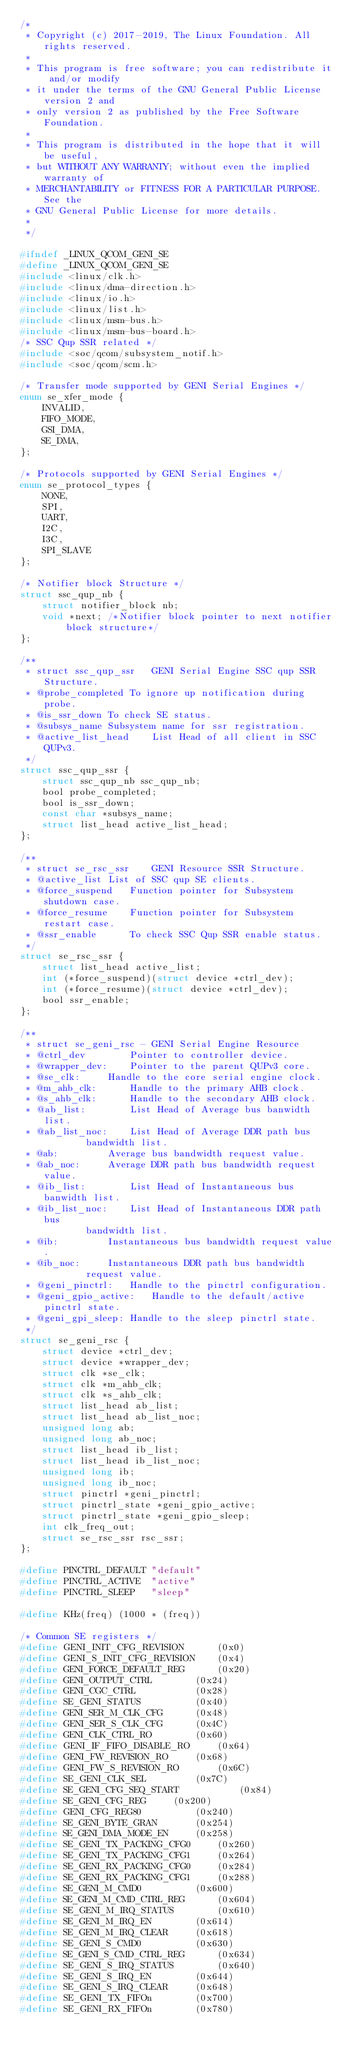Convert code to text. <code><loc_0><loc_0><loc_500><loc_500><_C_>/*
 * Copyright (c) 2017-2019, The Linux Foundation. All rights reserved.
 *
 * This program is free software; you can redistribute it and/or modify
 * it under the terms of the GNU General Public License version 2 and
 * only version 2 as published by the Free Software Foundation.
 *
 * This program is distributed in the hope that it will be useful,
 * but WITHOUT ANY WARRANTY; without even the implied warranty of
 * MERCHANTABILITY or FITNESS FOR A PARTICULAR PURPOSE.  See the
 * GNU General Public License for more details.
 *
 */

#ifndef _LINUX_QCOM_GENI_SE
#define _LINUX_QCOM_GENI_SE
#include <linux/clk.h>
#include <linux/dma-direction.h>
#include <linux/io.h>
#include <linux/list.h>
#include <linux/msm-bus.h>
#include <linux/msm-bus-board.h>
/* SSC Qup SSR related */
#include <soc/qcom/subsystem_notif.h>
#include <soc/qcom/scm.h>

/* Transfer mode supported by GENI Serial Engines */
enum se_xfer_mode {
	INVALID,
	FIFO_MODE,
	GSI_DMA,
	SE_DMA,
};

/* Protocols supported by GENI Serial Engines */
enum se_protocol_types {
	NONE,
	SPI,
	UART,
	I2C,
	I3C,
	SPI_SLAVE
};

/* Notifier block Structure */
struct ssc_qup_nb {
	struct notifier_block nb;
	void *next; /*Notifier block pointer to next notifier block structure*/
};

/**
 * struct ssc_qup_ssr	GENI Serial Engine SSC qup SSR Structure.
 * @probe_completed	To ignore up notification during probe.
 * @is_ssr_down	To check SE status.
 * @subsys_name	Subsystem name for ssr registration.
 * @active_list_head	List Head of all client in SSC QUPv3.
 */
struct ssc_qup_ssr {
	struct ssc_qup_nb ssc_qup_nb;
	bool probe_completed;
	bool is_ssr_down;
	const char *subsys_name;
	struct list_head active_list_head;
};

/**
 * struct se_rsc_ssr	GENI Resource SSR Structure.
 * @active_list	List of SSC qup SE clients.
 * @force_suspend	Function pointer for Subsystem shutdown case.
 * @force_resume	Function pointer for Subsystem restart case.
 * @ssr_enable		To check SSC Qup SSR enable status.
 */
struct se_rsc_ssr {
	struct list_head active_list;
	int (*force_suspend)(struct device *ctrl_dev);
	int (*force_resume)(struct device *ctrl_dev);
	bool ssr_enable;
};

/**
 * struct se_geni_rsc - GENI Serial Engine Resource
 * @ctrl_dev		Pointer to controller device.
 * @wrapper_dev:	Pointer to the parent QUPv3 core.
 * @se_clk:		Handle to the core serial engine clock.
 * @m_ahb_clk:		Handle to the primary AHB clock.
 * @s_ahb_clk:		Handle to the secondary AHB clock.
 * @ab_list:		List Head of Average bus banwidth list.
 * @ab_list_noc:	List Head of Average DDR path bus
			bandwidth list.
 * @ab:			Average bus bandwidth request value.
 * @ab_noc:		Average DDR path bus bandwidth request value.
 * @ib_list:		List Head of Instantaneous bus banwidth list.
 * @ib_list_noc:	List Head of Instantaneous DDR path bus
			bandwidth list.
 * @ib:			Instantaneous bus bandwidth request value.
 * @ib_noc:		Instantaneous DDR path bus bandwidth
			request value.
 * @geni_pinctrl:	Handle to the pinctrl configuration.
 * @geni_gpio_active:	Handle to the default/active pinctrl state.
 * @geni_gpi_sleep:	Handle to the sleep pinctrl state.
 */
struct se_geni_rsc {
	struct device *ctrl_dev;
	struct device *wrapper_dev;
	struct clk *se_clk;
	struct clk *m_ahb_clk;
	struct clk *s_ahb_clk;
	struct list_head ab_list;
	struct list_head ab_list_noc;
	unsigned long ab;
	unsigned long ab_noc;
	struct list_head ib_list;
	struct list_head ib_list_noc;
	unsigned long ib;
	unsigned long ib_noc;
	struct pinctrl *geni_pinctrl;
	struct pinctrl_state *geni_gpio_active;
	struct pinctrl_state *geni_gpio_sleep;
	int clk_freq_out;
	struct se_rsc_ssr rsc_ssr;
};

#define PINCTRL_DEFAULT	"default"
#define PINCTRL_ACTIVE	"active"
#define PINCTRL_SLEEP	"sleep"

#define KHz(freq) (1000 * (freq))

/* Common SE registers */
#define GENI_INIT_CFG_REVISION		(0x0)
#define GENI_S_INIT_CFG_REVISION	(0x4)
#define GENI_FORCE_DEFAULT_REG		(0x20)
#define GENI_OUTPUT_CTRL		(0x24)
#define GENI_CGC_CTRL			(0x28)
#define SE_GENI_STATUS			(0x40)
#define GENI_SER_M_CLK_CFG		(0x48)
#define GENI_SER_S_CLK_CFG		(0x4C)
#define GENI_CLK_CTRL_RO		(0x60)
#define GENI_IF_FIFO_DISABLE_RO		(0x64)
#define GENI_FW_REVISION_RO		(0x68)
#define GENI_FW_S_REVISION_RO		(0x6C)
#define SE_GENI_CLK_SEL			(0x7C)
#define SE_GENI_CFG_SEQ_START			(0x84)
#define SE_GENI_CFG_REG		(0x200)
#define GENI_CFG_REG80			(0x240)
#define SE_GENI_BYTE_GRAN		(0x254)
#define SE_GENI_DMA_MODE_EN		(0x258)
#define SE_GENI_TX_PACKING_CFG0		(0x260)
#define SE_GENI_TX_PACKING_CFG1		(0x264)
#define SE_GENI_RX_PACKING_CFG0		(0x284)
#define SE_GENI_RX_PACKING_CFG1		(0x288)
#define SE_GENI_M_CMD0			(0x600)
#define SE_GENI_M_CMD_CTRL_REG		(0x604)
#define SE_GENI_M_IRQ_STATUS		(0x610)
#define SE_GENI_M_IRQ_EN		(0x614)
#define SE_GENI_M_IRQ_CLEAR		(0x618)
#define SE_GENI_S_CMD0			(0x630)
#define SE_GENI_S_CMD_CTRL_REG		(0x634)
#define SE_GENI_S_IRQ_STATUS		(0x640)
#define SE_GENI_S_IRQ_EN		(0x644)
#define SE_GENI_S_IRQ_CLEAR		(0x648)
#define SE_GENI_TX_FIFOn		(0x700)
#define SE_GENI_RX_FIFOn		(0x780)</code> 